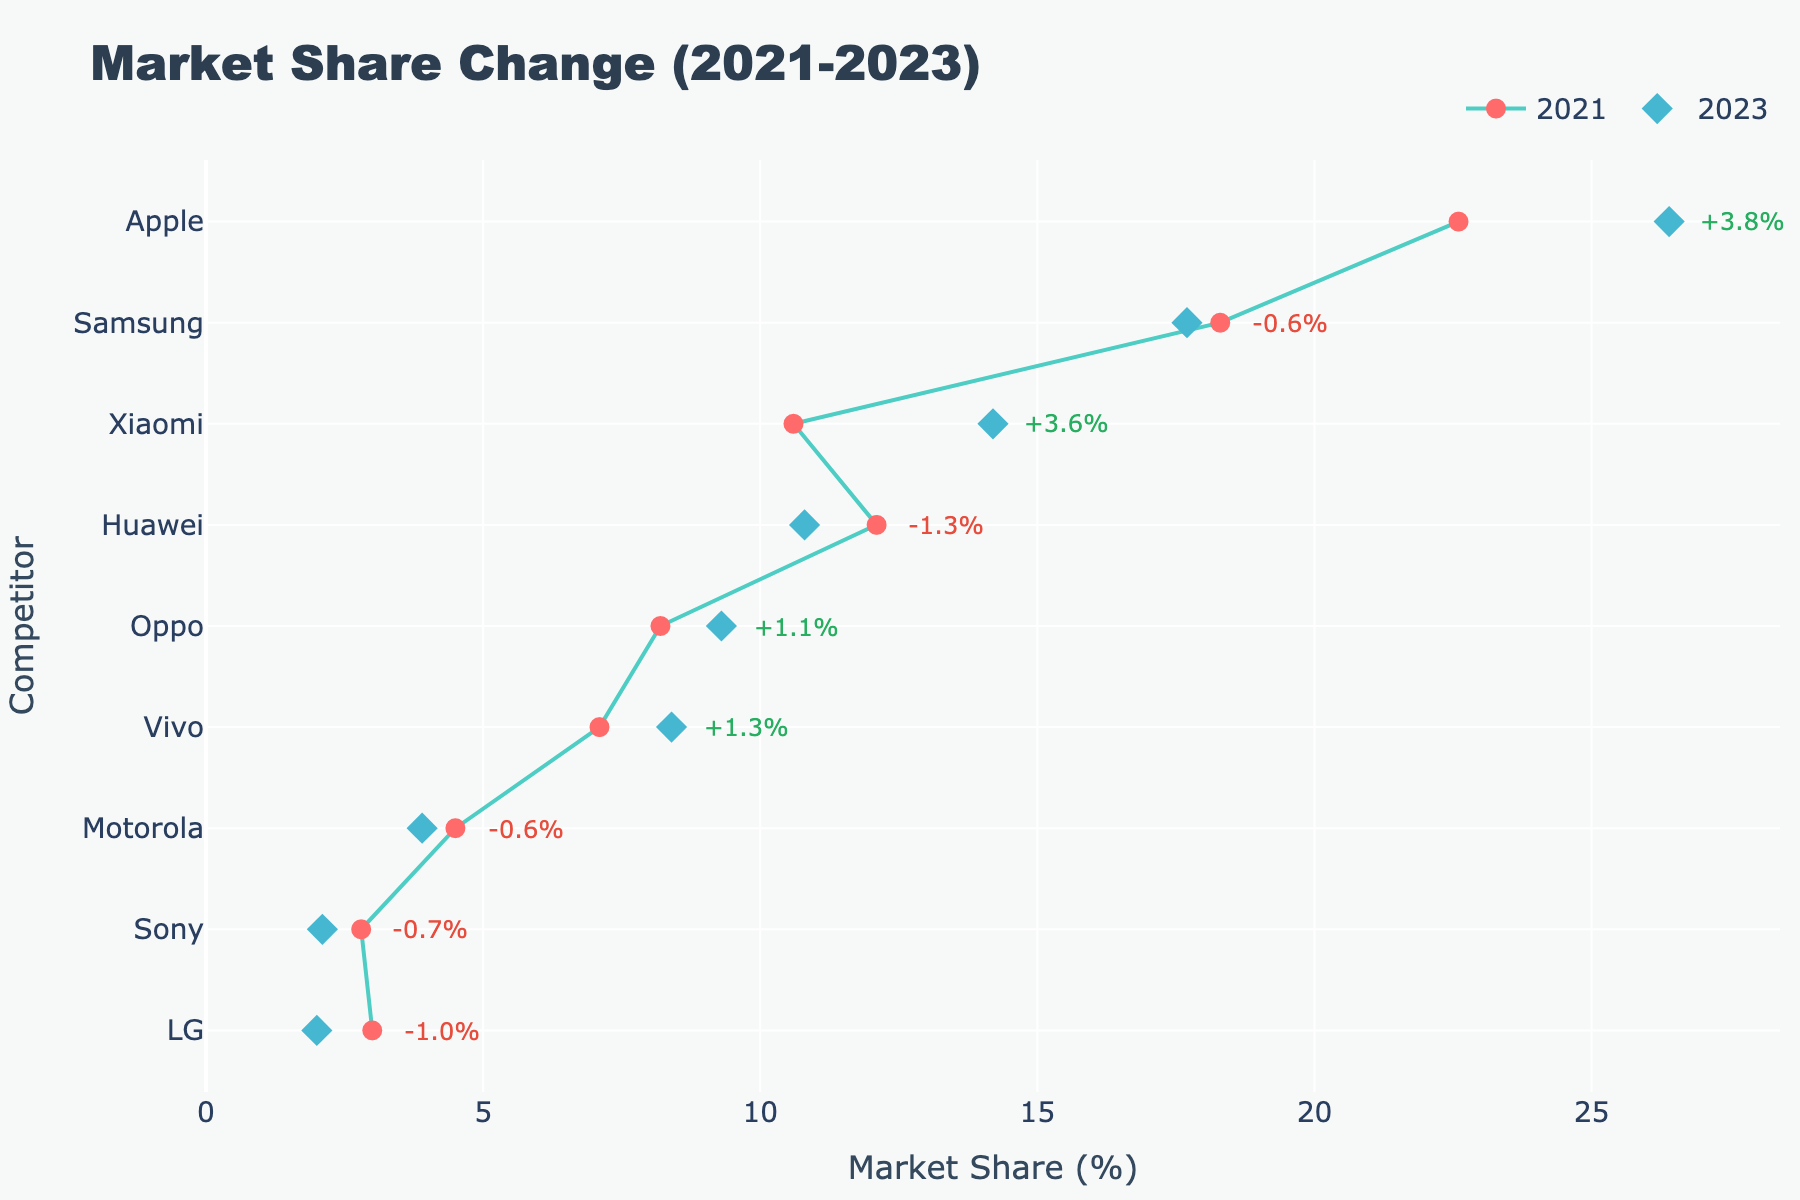What's the title of the figure? At the top of the figure, the title is displayed.
Answer: Market Share Change (2021-2023) What symbols are used for the 2021 and 2023 market share markers? The 2021 market share uses circles, and the 2023 market share uses diamonds.
Answer: Circles for 2021, Diamonds for 2023 Which company's market share increased the most from 2021 to 2023? By looking at the difference in the position of markers and the annotations, Xiaomi's market share increase is the most significant.
Answer: Xiaomi Which company experienced the most significant decrease in market share? By checking the annotations with negative values, LG experienced the most significant decrease in market share.
Answer: LG How much did Apple's market share change from 2021 to 2023? The annotation next to Apple shows the percentage change.
Answer: +3.8% What is the market share of Vivo in 2023? By finding the diamond marker aligned with Vivo on the y-axis, the value can be read from the x-axis.
Answer: 8.4% Which competitors had a market share decrease from 2021 to 2023? By identifying annotations with negative values next to the competitor names, we find Samsung, Huawei, Motorola, Sony, and LG had a decrease.
Answer: Samsung, Huawei, Motorola, Sony, LG How many competitors had an increased market share from 2021 to 2023? By counting the competitors with positive percent changes next to their names, there are four.
Answer: Four What is the range of market share values represented in the figure? The x-axis starts close to 0 and goes slightly beyond the highest market share value; from 0 to approximately 28 percent.
Answer: 0-28% Which competitor had a market share closest to 10% in 2023? By looking at the diamond marker positions, Xiaomi had a market share closest to 10% in 2023.
Answer: Xiaomi 